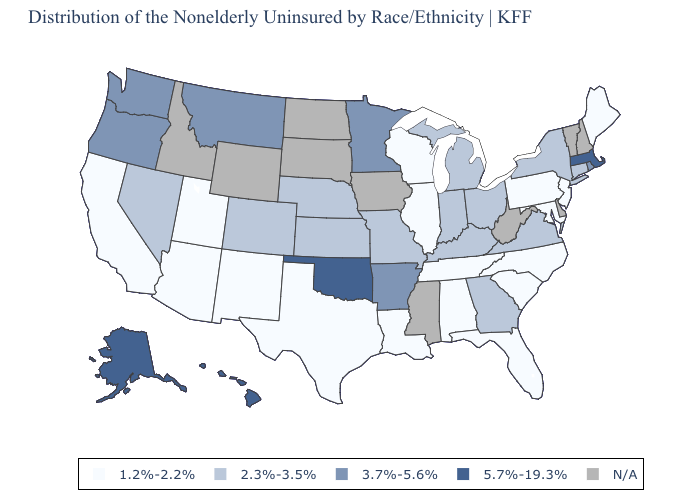Name the states that have a value in the range 3.7%-5.6%?
Be succinct. Arkansas, Minnesota, Montana, Oregon, Rhode Island, Washington. What is the value of Washington?
Quick response, please. 3.7%-5.6%. What is the lowest value in the USA?
Give a very brief answer. 1.2%-2.2%. What is the value of Kansas?
Give a very brief answer. 2.3%-3.5%. Does New York have the highest value in the Northeast?
Quick response, please. No. Among the states that border Florida , which have the lowest value?
Be succinct. Alabama. Does Georgia have the lowest value in the USA?
Answer briefly. No. What is the value of South Dakota?
Be succinct. N/A. Among the states that border New York , does Massachusetts have the lowest value?
Be succinct. No. Is the legend a continuous bar?
Give a very brief answer. No. What is the value of Kansas?
Quick response, please. 2.3%-3.5%. What is the value of Michigan?
Write a very short answer. 2.3%-3.5%. What is the value of Arkansas?
Quick response, please. 3.7%-5.6%. What is the value of South Carolina?
Give a very brief answer. 1.2%-2.2%. Is the legend a continuous bar?
Be succinct. No. 